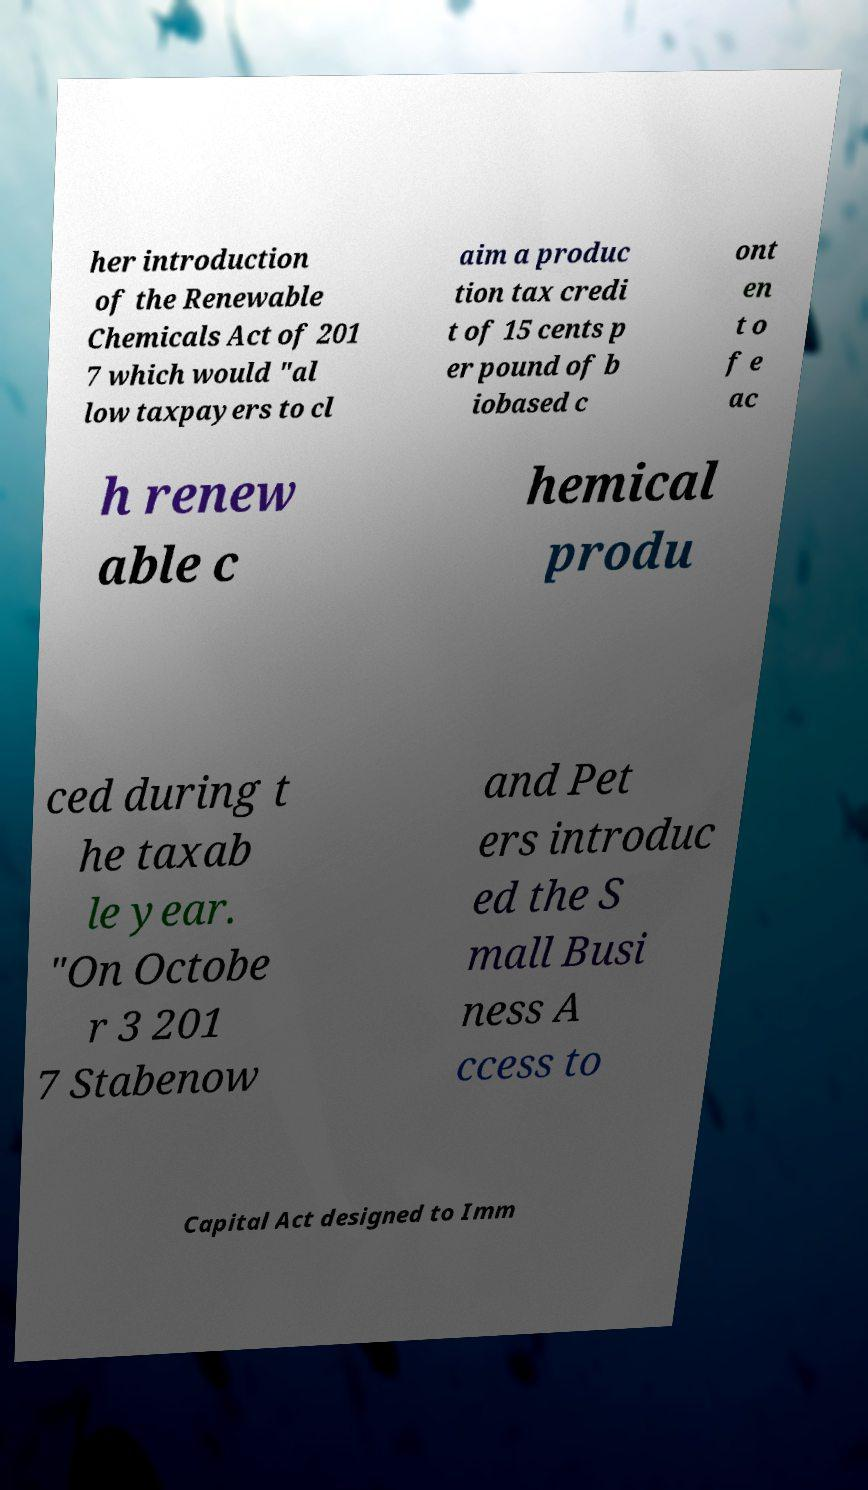For documentation purposes, I need the text within this image transcribed. Could you provide that? her introduction of the Renewable Chemicals Act of 201 7 which would "al low taxpayers to cl aim a produc tion tax credi t of 15 cents p er pound of b iobased c ont en t o f e ac h renew able c hemical produ ced during t he taxab le year. "On Octobe r 3 201 7 Stabenow and Pet ers introduc ed the S mall Busi ness A ccess to Capital Act designed to Imm 